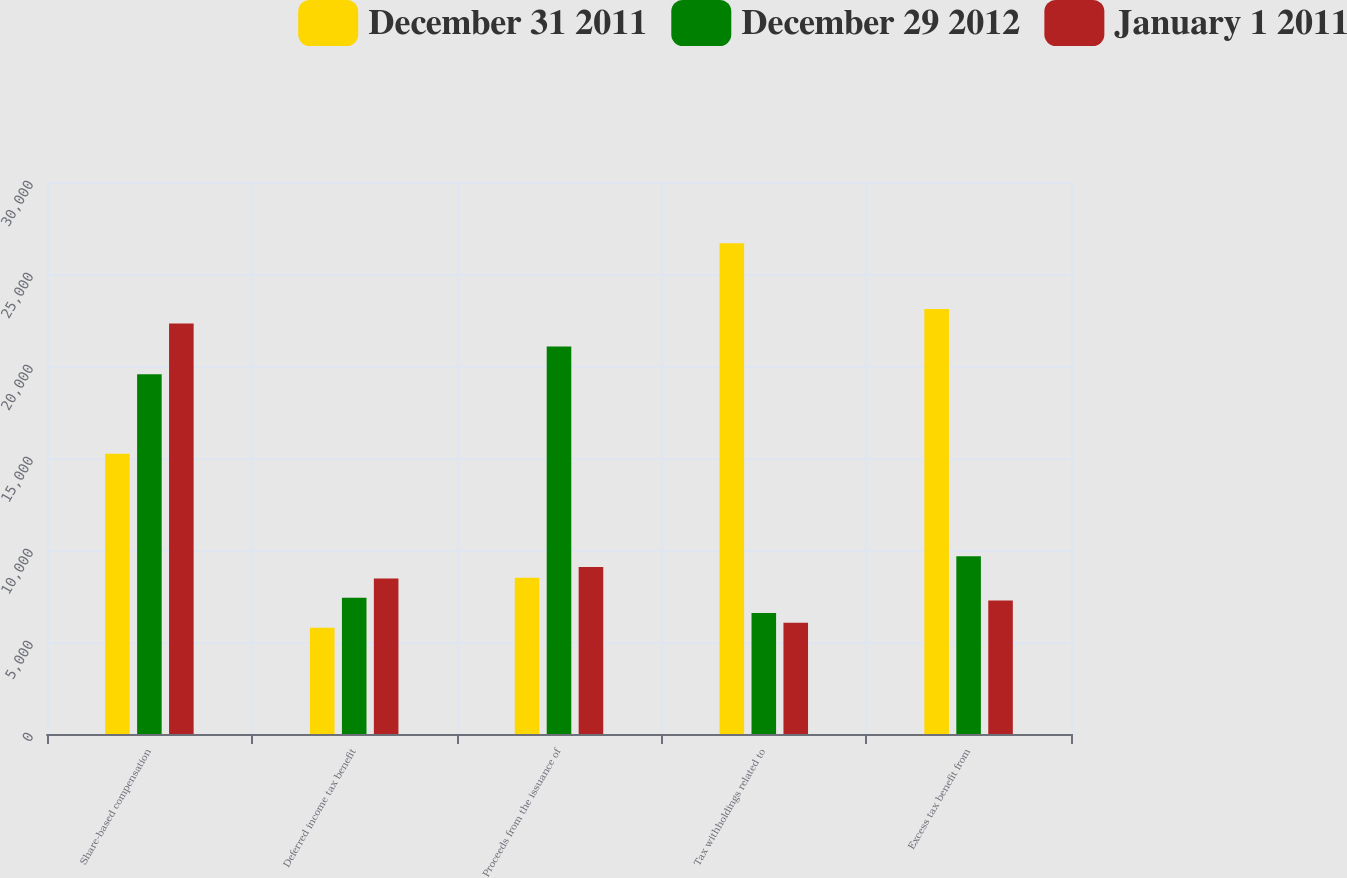<chart> <loc_0><loc_0><loc_500><loc_500><stacked_bar_chart><ecel><fcel>Share-based compensation<fcel>Deferred income tax benefit<fcel>Proceeds from the issuance of<fcel>Tax withholdings related to<fcel>Excess tax benefit from<nl><fcel>December 31 2011<fcel>15236<fcel>5774<fcel>8495<fcel>26677<fcel>23099<nl><fcel>December 29 2012<fcel>19553<fcel>7411<fcel>21056<fcel>6582<fcel>9663<nl><fcel>January 1 2011<fcel>22311<fcel>8456<fcel>9079<fcel>6047<fcel>7260<nl></chart> 